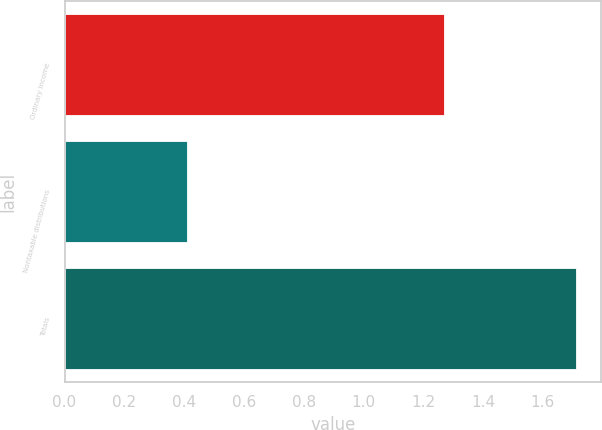<chart> <loc_0><loc_0><loc_500><loc_500><bar_chart><fcel>Ordinary income<fcel>Nontaxable distributions<fcel>Totals<nl><fcel>1.27<fcel>0.41<fcel>1.71<nl></chart> 